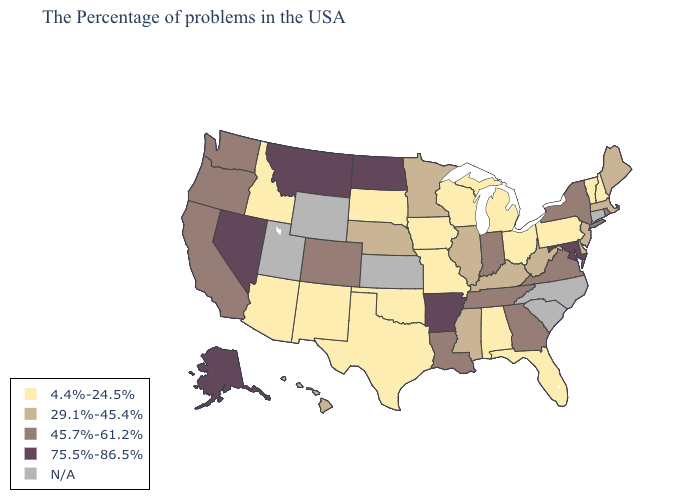Does the first symbol in the legend represent the smallest category?
Write a very short answer. Yes. Name the states that have a value in the range 29.1%-45.4%?
Be succinct. Maine, Massachusetts, New Jersey, Delaware, West Virginia, Kentucky, Illinois, Mississippi, Minnesota, Nebraska, Hawaii. Name the states that have a value in the range 45.7%-61.2%?
Be succinct. Rhode Island, New York, Virginia, Georgia, Indiana, Tennessee, Louisiana, Colorado, California, Washington, Oregon. Does the first symbol in the legend represent the smallest category?
Be succinct. Yes. Does the first symbol in the legend represent the smallest category?
Concise answer only. Yes. Which states have the highest value in the USA?
Concise answer only. Maryland, Arkansas, North Dakota, Montana, Nevada, Alaska. Does Minnesota have the highest value in the MidWest?
Concise answer only. No. Among the states that border Pennsylvania , which have the lowest value?
Concise answer only. Ohio. Name the states that have a value in the range 4.4%-24.5%?
Quick response, please. New Hampshire, Vermont, Pennsylvania, Ohio, Florida, Michigan, Alabama, Wisconsin, Missouri, Iowa, Oklahoma, Texas, South Dakota, New Mexico, Arizona, Idaho. Among the states that border Delaware , does Maryland have the lowest value?
Write a very short answer. No. What is the value of New Hampshire?
Answer briefly. 4.4%-24.5%. What is the highest value in states that border Missouri?
Write a very short answer. 75.5%-86.5%. What is the highest value in the Northeast ?
Keep it brief. 45.7%-61.2%. 